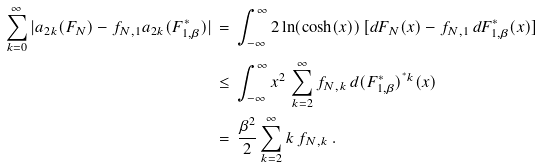Convert formula to latex. <formula><loc_0><loc_0><loc_500><loc_500>\sum _ { k = 0 } ^ { \infty } | a _ { 2 k } ( F _ { N } ) - f _ { N , 1 } a _ { 2 k } ( F ^ { * } _ { 1 , \beta } ) | \, & = \, \int _ { - \infty } ^ { \infty } 2 \ln ( \cosh ( x ) ) \, [ d F _ { N } ( x ) - f _ { N , 1 } \, d F ^ { * } _ { 1 , \beta } ( x ) ] \\ & \leq \, \int _ { - \infty } ^ { \infty } x ^ { 2 } \, \sum _ { k = 2 } ^ { \infty } f _ { N , k } \, d ( F ^ { * } _ { 1 , \beta } ) ^ { ^ { * } k } ( x ) \\ & = \, \frac { \beta ^ { 2 } } { 2 } \sum _ { k = 2 } ^ { \infty } k \, f _ { N , k } \, .</formula> 